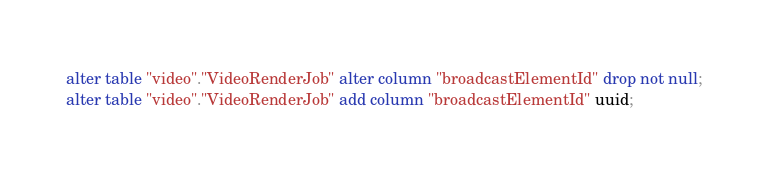Convert code to text. <code><loc_0><loc_0><loc_500><loc_500><_SQL_>alter table "video"."VideoRenderJob" alter column "broadcastElementId" drop not null;
alter table "video"."VideoRenderJob" add column "broadcastElementId" uuid;
</code> 